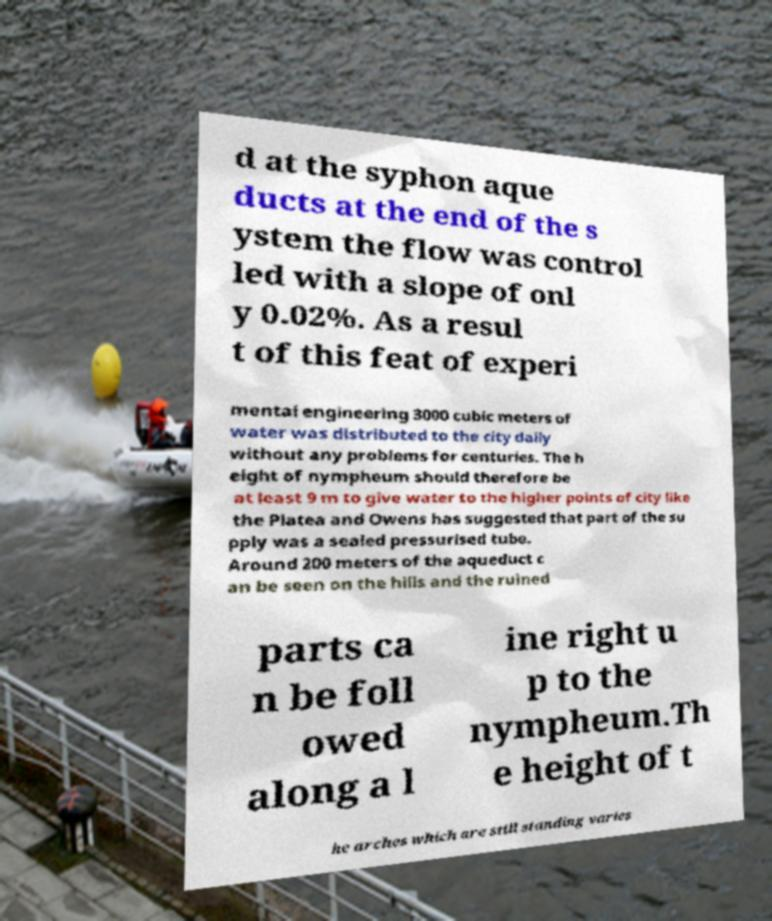Can you accurately transcribe the text from the provided image for me? d at the syphon aque ducts at the end of the s ystem the flow was control led with a slope of onl y 0.02%. As a resul t of this feat of experi mental engineering 3000 cubic meters of water was distributed to the city daily without any problems for centuries. The h eight of nympheum should therefore be at least 9 m to give water to the higher points of city like the Platea and Owens has suggested that part of the su pply was a sealed pressurised tube. Around 200 meters of the aqueduct c an be seen on the hills and the ruined parts ca n be foll owed along a l ine right u p to the nympheum.Th e height of t he arches which are still standing varies 